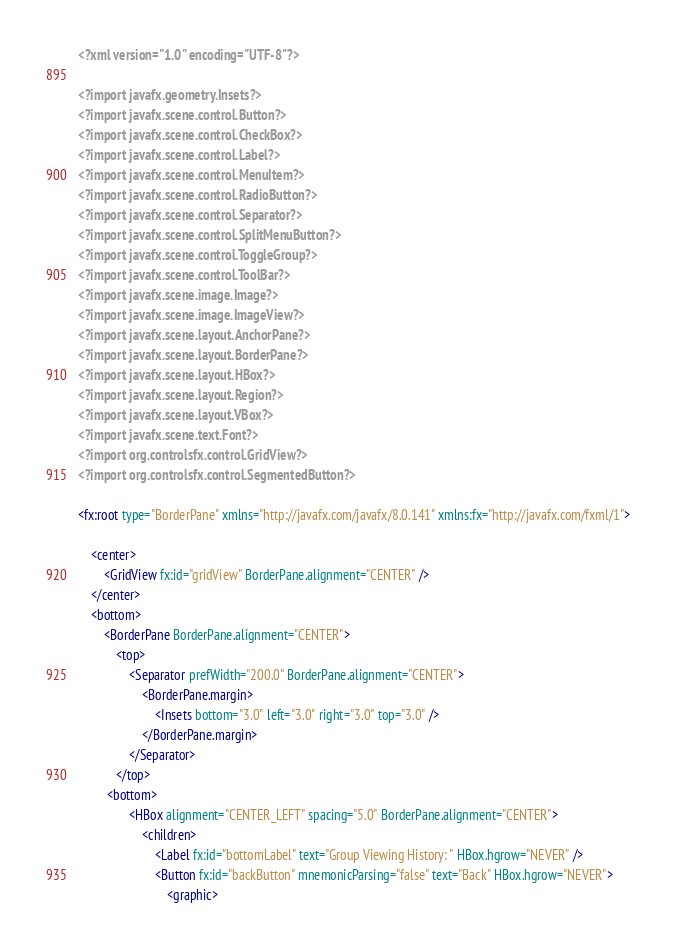Convert code to text. <code><loc_0><loc_0><loc_500><loc_500><_XML_><?xml version="1.0" encoding="UTF-8"?>

<?import javafx.geometry.Insets?>
<?import javafx.scene.control.Button?>
<?import javafx.scene.control.CheckBox?>
<?import javafx.scene.control.Label?>
<?import javafx.scene.control.MenuItem?>
<?import javafx.scene.control.RadioButton?>
<?import javafx.scene.control.Separator?>
<?import javafx.scene.control.SplitMenuButton?>
<?import javafx.scene.control.ToggleGroup?>
<?import javafx.scene.control.ToolBar?>
<?import javafx.scene.image.Image?>
<?import javafx.scene.image.ImageView?>
<?import javafx.scene.layout.AnchorPane?>
<?import javafx.scene.layout.BorderPane?>
<?import javafx.scene.layout.HBox?>
<?import javafx.scene.layout.Region?>
<?import javafx.scene.layout.VBox?>
<?import javafx.scene.text.Font?>
<?import org.controlsfx.control.GridView?>
<?import org.controlsfx.control.SegmentedButton?>

<fx:root type="BorderPane" xmlns="http://javafx.com/javafx/8.0.141" xmlns:fx="http://javafx.com/fxml/1">
   
    <center>
        <GridView fx:id="gridView" BorderPane.alignment="CENTER" />
    </center>
    <bottom>
        <BorderPane BorderPane.alignment="CENTER">
            <top>
                <Separator prefWidth="200.0" BorderPane.alignment="CENTER">
                    <BorderPane.margin>
                        <Insets bottom="3.0" left="3.0" right="3.0" top="3.0" />
                    </BorderPane.margin>
                </Separator>
            </top>
         <bottom>
                <HBox alignment="CENTER_LEFT" spacing="5.0" BorderPane.alignment="CENTER">
                    <children>
                        <Label fx:id="bottomLabel" text="Group Viewing History: " HBox.hgrow="NEVER" />
                        <Button fx:id="backButton" mnemonicParsing="false" text="Back" HBox.hgrow="NEVER">
                            <graphic></code> 